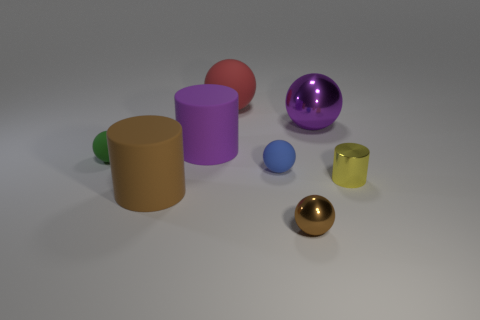How many other things are there of the same color as the small metal cylinder?
Ensure brevity in your answer.  0. There is a thing that is behind the yellow shiny cylinder and right of the brown ball; what is its shape?
Offer a terse response. Sphere. There is a green matte object that is behind the big object in front of the small blue ball; is there a small green matte ball that is behind it?
Your answer should be very brief. No. How many other things are the same material as the red sphere?
Your answer should be very brief. 4. What number of big red objects are there?
Give a very brief answer. 1. How many things are either big blue rubber balls or rubber things that are in front of the large metallic object?
Provide a succinct answer. 4. There is a cylinder behind the shiny cylinder; is it the same size as the tiny brown ball?
Ensure brevity in your answer.  No. What number of shiny things are either tiny yellow cylinders or blue cylinders?
Provide a short and direct response. 1. What is the size of the ball in front of the tiny metallic cylinder?
Provide a short and direct response. Small. Does the small brown thing have the same shape as the large red thing?
Make the answer very short. Yes. 